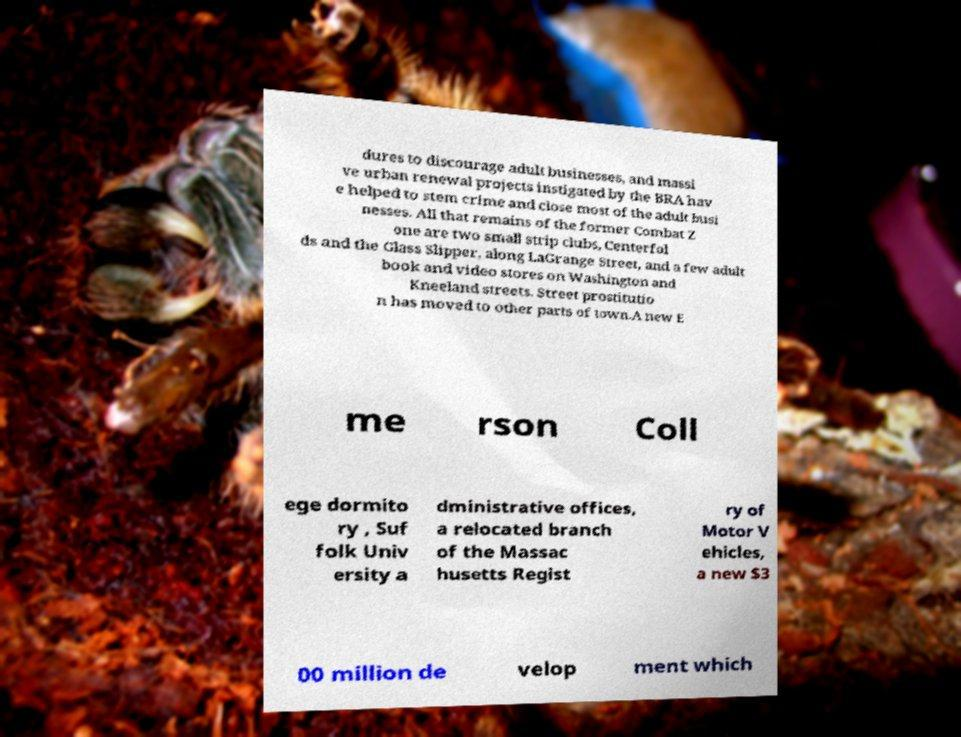What messages or text are displayed in this image? I need them in a readable, typed format. dures to discourage adult businesses, and massi ve urban renewal projects instigated by the BRA hav e helped to stem crime and close most of the adult busi nesses. All that remains of the former Combat Z one are two small strip clubs, Centerfol ds and the Glass Slipper, along LaGrange Street, and a few adult book and video stores on Washington and Kneeland streets. Street prostitutio n has moved to other parts of town.A new E me rson Coll ege dormito ry , Suf folk Univ ersity a dministrative offices, a relocated branch of the Massac husetts Regist ry of Motor V ehicles, a new $3 00 million de velop ment which 